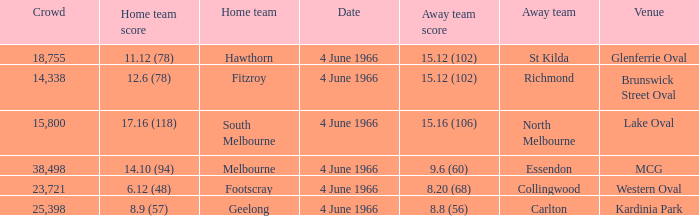What is the average crowd size of the away team who scored 9.6 (60)? 38498.0. Could you help me parse every detail presented in this table? {'header': ['Crowd', 'Home team score', 'Home team', 'Date', 'Away team score', 'Away team', 'Venue'], 'rows': [['18,755', '11.12 (78)', 'Hawthorn', '4 June 1966', '15.12 (102)', 'St Kilda', 'Glenferrie Oval'], ['14,338', '12.6 (78)', 'Fitzroy', '4 June 1966', '15.12 (102)', 'Richmond', 'Brunswick Street Oval'], ['15,800', '17.16 (118)', 'South Melbourne', '4 June 1966', '15.16 (106)', 'North Melbourne', 'Lake Oval'], ['38,498', '14.10 (94)', 'Melbourne', '4 June 1966', '9.6 (60)', 'Essendon', 'MCG'], ['23,721', '6.12 (48)', 'Footscray', '4 June 1966', '8.20 (68)', 'Collingwood', 'Western Oval'], ['25,398', '8.9 (57)', 'Geelong', '4 June 1966', '8.8 (56)', 'Carlton', 'Kardinia Park']]} 